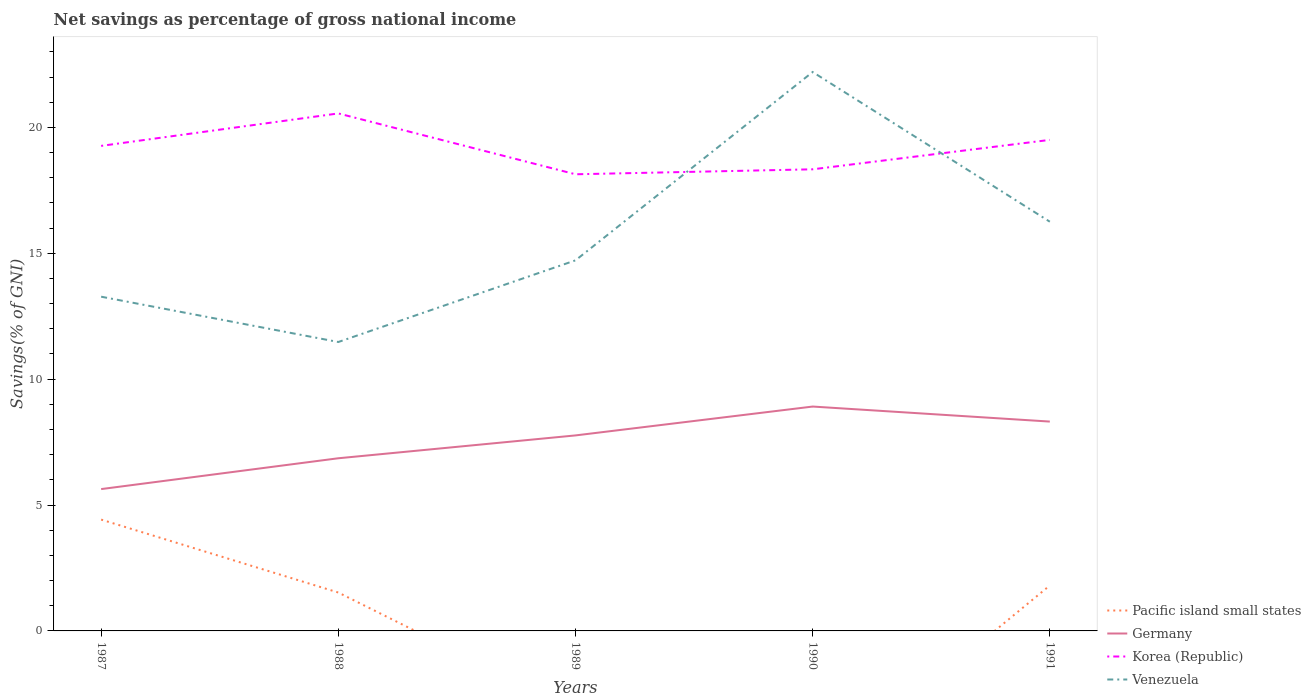Does the line corresponding to Germany intersect with the line corresponding to Korea (Republic)?
Your answer should be very brief. No. Is the number of lines equal to the number of legend labels?
Your answer should be compact. No. Across all years, what is the maximum total savings in Pacific island small states?
Offer a very short reply. 0. What is the total total savings in Venezuela in the graph?
Provide a short and direct response. -7.48. What is the difference between the highest and the second highest total savings in Pacific island small states?
Make the answer very short. 4.42. What is the difference between the highest and the lowest total savings in Venezuela?
Keep it short and to the point. 2. How many lines are there?
Your response must be concise. 4. Are the values on the major ticks of Y-axis written in scientific E-notation?
Offer a terse response. No. What is the title of the graph?
Offer a terse response. Net savings as percentage of gross national income. What is the label or title of the Y-axis?
Keep it short and to the point. Savings(% of GNI). What is the Savings(% of GNI) in Pacific island small states in 1987?
Offer a terse response. 4.42. What is the Savings(% of GNI) of Germany in 1987?
Offer a very short reply. 5.63. What is the Savings(% of GNI) in Korea (Republic) in 1987?
Give a very brief answer. 19.26. What is the Savings(% of GNI) of Venezuela in 1987?
Offer a very short reply. 13.27. What is the Savings(% of GNI) in Pacific island small states in 1988?
Your answer should be compact. 1.52. What is the Savings(% of GNI) of Germany in 1988?
Your answer should be very brief. 6.86. What is the Savings(% of GNI) of Korea (Republic) in 1988?
Provide a short and direct response. 20.55. What is the Savings(% of GNI) in Venezuela in 1988?
Your response must be concise. 11.48. What is the Savings(% of GNI) in Pacific island small states in 1989?
Your response must be concise. 0. What is the Savings(% of GNI) in Germany in 1989?
Provide a short and direct response. 7.77. What is the Savings(% of GNI) in Korea (Republic) in 1989?
Provide a succinct answer. 18.14. What is the Savings(% of GNI) of Venezuela in 1989?
Keep it short and to the point. 14.72. What is the Savings(% of GNI) in Germany in 1990?
Provide a succinct answer. 8.91. What is the Savings(% of GNI) in Korea (Republic) in 1990?
Provide a succinct answer. 18.33. What is the Savings(% of GNI) of Venezuela in 1990?
Your answer should be very brief. 22.2. What is the Savings(% of GNI) in Pacific island small states in 1991?
Give a very brief answer. 1.81. What is the Savings(% of GNI) in Germany in 1991?
Your response must be concise. 8.31. What is the Savings(% of GNI) of Korea (Republic) in 1991?
Offer a terse response. 19.5. What is the Savings(% of GNI) of Venezuela in 1991?
Provide a succinct answer. 16.25. Across all years, what is the maximum Savings(% of GNI) of Pacific island small states?
Make the answer very short. 4.42. Across all years, what is the maximum Savings(% of GNI) of Germany?
Offer a very short reply. 8.91. Across all years, what is the maximum Savings(% of GNI) of Korea (Republic)?
Offer a very short reply. 20.55. Across all years, what is the maximum Savings(% of GNI) in Venezuela?
Ensure brevity in your answer.  22.2. Across all years, what is the minimum Savings(% of GNI) in Germany?
Offer a very short reply. 5.63. Across all years, what is the minimum Savings(% of GNI) of Korea (Republic)?
Your answer should be compact. 18.14. Across all years, what is the minimum Savings(% of GNI) of Venezuela?
Your answer should be very brief. 11.48. What is the total Savings(% of GNI) of Pacific island small states in the graph?
Offer a very short reply. 7.75. What is the total Savings(% of GNI) of Germany in the graph?
Keep it short and to the point. 37.48. What is the total Savings(% of GNI) in Korea (Republic) in the graph?
Ensure brevity in your answer.  95.79. What is the total Savings(% of GNI) of Venezuela in the graph?
Keep it short and to the point. 77.92. What is the difference between the Savings(% of GNI) in Pacific island small states in 1987 and that in 1988?
Make the answer very short. 2.9. What is the difference between the Savings(% of GNI) of Germany in 1987 and that in 1988?
Offer a very short reply. -1.22. What is the difference between the Savings(% of GNI) of Korea (Republic) in 1987 and that in 1988?
Ensure brevity in your answer.  -1.29. What is the difference between the Savings(% of GNI) in Venezuela in 1987 and that in 1988?
Provide a short and direct response. 1.8. What is the difference between the Savings(% of GNI) in Germany in 1987 and that in 1989?
Your answer should be very brief. -2.13. What is the difference between the Savings(% of GNI) of Korea (Republic) in 1987 and that in 1989?
Ensure brevity in your answer.  1.13. What is the difference between the Savings(% of GNI) of Venezuela in 1987 and that in 1989?
Your answer should be very brief. -1.44. What is the difference between the Savings(% of GNI) in Germany in 1987 and that in 1990?
Your response must be concise. -3.28. What is the difference between the Savings(% of GNI) of Korea (Republic) in 1987 and that in 1990?
Give a very brief answer. 0.93. What is the difference between the Savings(% of GNI) of Venezuela in 1987 and that in 1990?
Make the answer very short. -8.92. What is the difference between the Savings(% of GNI) of Pacific island small states in 1987 and that in 1991?
Your answer should be very brief. 2.62. What is the difference between the Savings(% of GNI) in Germany in 1987 and that in 1991?
Provide a succinct answer. -2.68. What is the difference between the Savings(% of GNI) in Korea (Republic) in 1987 and that in 1991?
Offer a terse response. -0.24. What is the difference between the Savings(% of GNI) in Venezuela in 1987 and that in 1991?
Offer a terse response. -2.98. What is the difference between the Savings(% of GNI) in Germany in 1988 and that in 1989?
Your answer should be compact. -0.91. What is the difference between the Savings(% of GNI) in Korea (Republic) in 1988 and that in 1989?
Provide a succinct answer. 2.42. What is the difference between the Savings(% of GNI) in Venezuela in 1988 and that in 1989?
Give a very brief answer. -3.24. What is the difference between the Savings(% of GNI) in Germany in 1988 and that in 1990?
Your answer should be compact. -2.05. What is the difference between the Savings(% of GNI) in Korea (Republic) in 1988 and that in 1990?
Make the answer very short. 2.22. What is the difference between the Savings(% of GNI) of Venezuela in 1988 and that in 1990?
Ensure brevity in your answer.  -10.72. What is the difference between the Savings(% of GNI) of Pacific island small states in 1988 and that in 1991?
Make the answer very short. -0.28. What is the difference between the Savings(% of GNI) in Germany in 1988 and that in 1991?
Provide a short and direct response. -1.46. What is the difference between the Savings(% of GNI) in Korea (Republic) in 1988 and that in 1991?
Offer a very short reply. 1.05. What is the difference between the Savings(% of GNI) in Venezuela in 1988 and that in 1991?
Your answer should be compact. -4.78. What is the difference between the Savings(% of GNI) of Germany in 1989 and that in 1990?
Make the answer very short. -1.15. What is the difference between the Savings(% of GNI) of Korea (Republic) in 1989 and that in 1990?
Your response must be concise. -0.2. What is the difference between the Savings(% of GNI) of Venezuela in 1989 and that in 1990?
Your response must be concise. -7.48. What is the difference between the Savings(% of GNI) in Germany in 1989 and that in 1991?
Offer a terse response. -0.55. What is the difference between the Savings(% of GNI) of Korea (Republic) in 1989 and that in 1991?
Give a very brief answer. -1.37. What is the difference between the Savings(% of GNI) in Venezuela in 1989 and that in 1991?
Offer a very short reply. -1.53. What is the difference between the Savings(% of GNI) in Germany in 1990 and that in 1991?
Ensure brevity in your answer.  0.6. What is the difference between the Savings(% of GNI) of Korea (Republic) in 1990 and that in 1991?
Provide a short and direct response. -1.17. What is the difference between the Savings(% of GNI) in Venezuela in 1990 and that in 1991?
Make the answer very short. 5.95. What is the difference between the Savings(% of GNI) in Pacific island small states in 1987 and the Savings(% of GNI) in Germany in 1988?
Provide a succinct answer. -2.44. What is the difference between the Savings(% of GNI) in Pacific island small states in 1987 and the Savings(% of GNI) in Korea (Republic) in 1988?
Your response must be concise. -16.13. What is the difference between the Savings(% of GNI) in Pacific island small states in 1987 and the Savings(% of GNI) in Venezuela in 1988?
Your answer should be compact. -7.05. What is the difference between the Savings(% of GNI) of Germany in 1987 and the Savings(% of GNI) of Korea (Republic) in 1988?
Provide a succinct answer. -14.92. What is the difference between the Savings(% of GNI) of Germany in 1987 and the Savings(% of GNI) of Venezuela in 1988?
Provide a succinct answer. -5.84. What is the difference between the Savings(% of GNI) in Korea (Republic) in 1987 and the Savings(% of GNI) in Venezuela in 1988?
Ensure brevity in your answer.  7.79. What is the difference between the Savings(% of GNI) in Pacific island small states in 1987 and the Savings(% of GNI) in Germany in 1989?
Offer a very short reply. -3.34. What is the difference between the Savings(% of GNI) in Pacific island small states in 1987 and the Savings(% of GNI) in Korea (Republic) in 1989?
Offer a very short reply. -13.72. What is the difference between the Savings(% of GNI) of Pacific island small states in 1987 and the Savings(% of GNI) of Venezuela in 1989?
Offer a terse response. -10.3. What is the difference between the Savings(% of GNI) in Germany in 1987 and the Savings(% of GNI) in Korea (Republic) in 1989?
Your answer should be compact. -12.5. What is the difference between the Savings(% of GNI) of Germany in 1987 and the Savings(% of GNI) of Venezuela in 1989?
Your response must be concise. -9.09. What is the difference between the Savings(% of GNI) in Korea (Republic) in 1987 and the Savings(% of GNI) in Venezuela in 1989?
Your answer should be very brief. 4.55. What is the difference between the Savings(% of GNI) of Pacific island small states in 1987 and the Savings(% of GNI) of Germany in 1990?
Offer a terse response. -4.49. What is the difference between the Savings(% of GNI) in Pacific island small states in 1987 and the Savings(% of GNI) in Korea (Republic) in 1990?
Your response must be concise. -13.91. What is the difference between the Savings(% of GNI) in Pacific island small states in 1987 and the Savings(% of GNI) in Venezuela in 1990?
Keep it short and to the point. -17.78. What is the difference between the Savings(% of GNI) in Germany in 1987 and the Savings(% of GNI) in Korea (Republic) in 1990?
Keep it short and to the point. -12.7. What is the difference between the Savings(% of GNI) in Germany in 1987 and the Savings(% of GNI) in Venezuela in 1990?
Provide a succinct answer. -16.57. What is the difference between the Savings(% of GNI) of Korea (Republic) in 1987 and the Savings(% of GNI) of Venezuela in 1990?
Your response must be concise. -2.93. What is the difference between the Savings(% of GNI) of Pacific island small states in 1987 and the Savings(% of GNI) of Germany in 1991?
Your answer should be compact. -3.89. What is the difference between the Savings(% of GNI) in Pacific island small states in 1987 and the Savings(% of GNI) in Korea (Republic) in 1991?
Keep it short and to the point. -15.08. What is the difference between the Savings(% of GNI) in Pacific island small states in 1987 and the Savings(% of GNI) in Venezuela in 1991?
Keep it short and to the point. -11.83. What is the difference between the Savings(% of GNI) of Germany in 1987 and the Savings(% of GNI) of Korea (Republic) in 1991?
Your answer should be compact. -13.87. What is the difference between the Savings(% of GNI) in Germany in 1987 and the Savings(% of GNI) in Venezuela in 1991?
Ensure brevity in your answer.  -10.62. What is the difference between the Savings(% of GNI) of Korea (Republic) in 1987 and the Savings(% of GNI) of Venezuela in 1991?
Provide a short and direct response. 3.01. What is the difference between the Savings(% of GNI) in Pacific island small states in 1988 and the Savings(% of GNI) in Germany in 1989?
Your response must be concise. -6.24. What is the difference between the Savings(% of GNI) of Pacific island small states in 1988 and the Savings(% of GNI) of Korea (Republic) in 1989?
Provide a succinct answer. -16.61. What is the difference between the Savings(% of GNI) of Pacific island small states in 1988 and the Savings(% of GNI) of Venezuela in 1989?
Give a very brief answer. -13.19. What is the difference between the Savings(% of GNI) of Germany in 1988 and the Savings(% of GNI) of Korea (Republic) in 1989?
Your answer should be compact. -11.28. What is the difference between the Savings(% of GNI) of Germany in 1988 and the Savings(% of GNI) of Venezuela in 1989?
Make the answer very short. -7.86. What is the difference between the Savings(% of GNI) of Korea (Republic) in 1988 and the Savings(% of GNI) of Venezuela in 1989?
Keep it short and to the point. 5.84. What is the difference between the Savings(% of GNI) in Pacific island small states in 1988 and the Savings(% of GNI) in Germany in 1990?
Provide a succinct answer. -7.39. What is the difference between the Savings(% of GNI) of Pacific island small states in 1988 and the Savings(% of GNI) of Korea (Republic) in 1990?
Give a very brief answer. -16.81. What is the difference between the Savings(% of GNI) in Pacific island small states in 1988 and the Savings(% of GNI) in Venezuela in 1990?
Offer a terse response. -20.67. What is the difference between the Savings(% of GNI) of Germany in 1988 and the Savings(% of GNI) of Korea (Republic) in 1990?
Offer a very short reply. -11.48. What is the difference between the Savings(% of GNI) of Germany in 1988 and the Savings(% of GNI) of Venezuela in 1990?
Your answer should be very brief. -15.34. What is the difference between the Savings(% of GNI) of Korea (Republic) in 1988 and the Savings(% of GNI) of Venezuela in 1990?
Keep it short and to the point. -1.64. What is the difference between the Savings(% of GNI) of Pacific island small states in 1988 and the Savings(% of GNI) of Germany in 1991?
Offer a very short reply. -6.79. What is the difference between the Savings(% of GNI) of Pacific island small states in 1988 and the Savings(% of GNI) of Korea (Republic) in 1991?
Your answer should be compact. -17.98. What is the difference between the Savings(% of GNI) in Pacific island small states in 1988 and the Savings(% of GNI) in Venezuela in 1991?
Offer a very short reply. -14.73. What is the difference between the Savings(% of GNI) in Germany in 1988 and the Savings(% of GNI) in Korea (Republic) in 1991?
Ensure brevity in your answer.  -12.65. What is the difference between the Savings(% of GNI) of Germany in 1988 and the Savings(% of GNI) of Venezuela in 1991?
Keep it short and to the point. -9.4. What is the difference between the Savings(% of GNI) in Korea (Republic) in 1988 and the Savings(% of GNI) in Venezuela in 1991?
Your response must be concise. 4.3. What is the difference between the Savings(% of GNI) in Germany in 1989 and the Savings(% of GNI) in Korea (Republic) in 1990?
Offer a terse response. -10.57. What is the difference between the Savings(% of GNI) of Germany in 1989 and the Savings(% of GNI) of Venezuela in 1990?
Provide a succinct answer. -14.43. What is the difference between the Savings(% of GNI) in Korea (Republic) in 1989 and the Savings(% of GNI) in Venezuela in 1990?
Offer a terse response. -4.06. What is the difference between the Savings(% of GNI) in Germany in 1989 and the Savings(% of GNI) in Korea (Republic) in 1991?
Ensure brevity in your answer.  -11.74. What is the difference between the Savings(% of GNI) of Germany in 1989 and the Savings(% of GNI) of Venezuela in 1991?
Keep it short and to the point. -8.49. What is the difference between the Savings(% of GNI) in Korea (Republic) in 1989 and the Savings(% of GNI) in Venezuela in 1991?
Provide a succinct answer. 1.88. What is the difference between the Savings(% of GNI) of Germany in 1990 and the Savings(% of GNI) of Korea (Republic) in 1991?
Your answer should be very brief. -10.59. What is the difference between the Savings(% of GNI) of Germany in 1990 and the Savings(% of GNI) of Venezuela in 1991?
Make the answer very short. -7.34. What is the difference between the Savings(% of GNI) in Korea (Republic) in 1990 and the Savings(% of GNI) in Venezuela in 1991?
Your answer should be compact. 2.08. What is the average Savings(% of GNI) of Pacific island small states per year?
Give a very brief answer. 1.55. What is the average Savings(% of GNI) in Germany per year?
Provide a succinct answer. 7.5. What is the average Savings(% of GNI) of Korea (Republic) per year?
Make the answer very short. 19.16. What is the average Savings(% of GNI) in Venezuela per year?
Your response must be concise. 15.58. In the year 1987, what is the difference between the Savings(% of GNI) of Pacific island small states and Savings(% of GNI) of Germany?
Give a very brief answer. -1.21. In the year 1987, what is the difference between the Savings(% of GNI) of Pacific island small states and Savings(% of GNI) of Korea (Republic)?
Keep it short and to the point. -14.84. In the year 1987, what is the difference between the Savings(% of GNI) in Pacific island small states and Savings(% of GNI) in Venezuela?
Your response must be concise. -8.85. In the year 1987, what is the difference between the Savings(% of GNI) of Germany and Savings(% of GNI) of Korea (Republic)?
Your response must be concise. -13.63. In the year 1987, what is the difference between the Savings(% of GNI) in Germany and Savings(% of GNI) in Venezuela?
Make the answer very short. -7.64. In the year 1987, what is the difference between the Savings(% of GNI) in Korea (Republic) and Savings(% of GNI) in Venezuela?
Ensure brevity in your answer.  5.99. In the year 1988, what is the difference between the Savings(% of GNI) in Pacific island small states and Savings(% of GNI) in Germany?
Make the answer very short. -5.33. In the year 1988, what is the difference between the Savings(% of GNI) in Pacific island small states and Savings(% of GNI) in Korea (Republic)?
Keep it short and to the point. -19.03. In the year 1988, what is the difference between the Savings(% of GNI) of Pacific island small states and Savings(% of GNI) of Venezuela?
Your response must be concise. -9.95. In the year 1988, what is the difference between the Savings(% of GNI) in Germany and Savings(% of GNI) in Korea (Republic)?
Give a very brief answer. -13.7. In the year 1988, what is the difference between the Savings(% of GNI) in Germany and Savings(% of GNI) in Venezuela?
Your answer should be compact. -4.62. In the year 1988, what is the difference between the Savings(% of GNI) of Korea (Republic) and Savings(% of GNI) of Venezuela?
Ensure brevity in your answer.  9.08. In the year 1989, what is the difference between the Savings(% of GNI) of Germany and Savings(% of GNI) of Korea (Republic)?
Make the answer very short. -10.37. In the year 1989, what is the difference between the Savings(% of GNI) in Germany and Savings(% of GNI) in Venezuela?
Give a very brief answer. -6.95. In the year 1989, what is the difference between the Savings(% of GNI) of Korea (Republic) and Savings(% of GNI) of Venezuela?
Ensure brevity in your answer.  3.42. In the year 1990, what is the difference between the Savings(% of GNI) in Germany and Savings(% of GNI) in Korea (Republic)?
Offer a terse response. -9.42. In the year 1990, what is the difference between the Savings(% of GNI) of Germany and Savings(% of GNI) of Venezuela?
Offer a terse response. -13.29. In the year 1990, what is the difference between the Savings(% of GNI) of Korea (Republic) and Savings(% of GNI) of Venezuela?
Give a very brief answer. -3.86. In the year 1991, what is the difference between the Savings(% of GNI) in Pacific island small states and Savings(% of GNI) in Germany?
Your response must be concise. -6.51. In the year 1991, what is the difference between the Savings(% of GNI) in Pacific island small states and Savings(% of GNI) in Korea (Republic)?
Make the answer very short. -17.7. In the year 1991, what is the difference between the Savings(% of GNI) of Pacific island small states and Savings(% of GNI) of Venezuela?
Provide a succinct answer. -14.45. In the year 1991, what is the difference between the Savings(% of GNI) of Germany and Savings(% of GNI) of Korea (Republic)?
Provide a short and direct response. -11.19. In the year 1991, what is the difference between the Savings(% of GNI) of Germany and Savings(% of GNI) of Venezuela?
Give a very brief answer. -7.94. In the year 1991, what is the difference between the Savings(% of GNI) of Korea (Republic) and Savings(% of GNI) of Venezuela?
Offer a very short reply. 3.25. What is the ratio of the Savings(% of GNI) in Pacific island small states in 1987 to that in 1988?
Your answer should be very brief. 2.9. What is the ratio of the Savings(% of GNI) in Germany in 1987 to that in 1988?
Make the answer very short. 0.82. What is the ratio of the Savings(% of GNI) in Korea (Republic) in 1987 to that in 1988?
Offer a very short reply. 0.94. What is the ratio of the Savings(% of GNI) in Venezuela in 1987 to that in 1988?
Your answer should be very brief. 1.16. What is the ratio of the Savings(% of GNI) in Germany in 1987 to that in 1989?
Make the answer very short. 0.73. What is the ratio of the Savings(% of GNI) of Korea (Republic) in 1987 to that in 1989?
Your response must be concise. 1.06. What is the ratio of the Savings(% of GNI) in Venezuela in 1987 to that in 1989?
Keep it short and to the point. 0.9. What is the ratio of the Savings(% of GNI) of Germany in 1987 to that in 1990?
Your response must be concise. 0.63. What is the ratio of the Savings(% of GNI) of Korea (Republic) in 1987 to that in 1990?
Ensure brevity in your answer.  1.05. What is the ratio of the Savings(% of GNI) of Venezuela in 1987 to that in 1990?
Give a very brief answer. 0.6. What is the ratio of the Savings(% of GNI) in Pacific island small states in 1987 to that in 1991?
Make the answer very short. 2.45. What is the ratio of the Savings(% of GNI) of Germany in 1987 to that in 1991?
Provide a succinct answer. 0.68. What is the ratio of the Savings(% of GNI) in Venezuela in 1987 to that in 1991?
Make the answer very short. 0.82. What is the ratio of the Savings(% of GNI) in Germany in 1988 to that in 1989?
Your response must be concise. 0.88. What is the ratio of the Savings(% of GNI) in Korea (Republic) in 1988 to that in 1989?
Offer a terse response. 1.13. What is the ratio of the Savings(% of GNI) of Venezuela in 1988 to that in 1989?
Keep it short and to the point. 0.78. What is the ratio of the Savings(% of GNI) in Germany in 1988 to that in 1990?
Your answer should be compact. 0.77. What is the ratio of the Savings(% of GNI) in Korea (Republic) in 1988 to that in 1990?
Keep it short and to the point. 1.12. What is the ratio of the Savings(% of GNI) of Venezuela in 1988 to that in 1990?
Your response must be concise. 0.52. What is the ratio of the Savings(% of GNI) in Pacific island small states in 1988 to that in 1991?
Provide a short and direct response. 0.84. What is the ratio of the Savings(% of GNI) of Germany in 1988 to that in 1991?
Provide a short and direct response. 0.82. What is the ratio of the Savings(% of GNI) of Korea (Republic) in 1988 to that in 1991?
Offer a very short reply. 1.05. What is the ratio of the Savings(% of GNI) in Venezuela in 1988 to that in 1991?
Keep it short and to the point. 0.71. What is the ratio of the Savings(% of GNI) in Germany in 1989 to that in 1990?
Your answer should be compact. 0.87. What is the ratio of the Savings(% of GNI) of Korea (Republic) in 1989 to that in 1990?
Offer a terse response. 0.99. What is the ratio of the Savings(% of GNI) of Venezuela in 1989 to that in 1990?
Provide a succinct answer. 0.66. What is the ratio of the Savings(% of GNI) in Germany in 1989 to that in 1991?
Offer a terse response. 0.93. What is the ratio of the Savings(% of GNI) of Korea (Republic) in 1989 to that in 1991?
Offer a terse response. 0.93. What is the ratio of the Savings(% of GNI) in Venezuela in 1989 to that in 1991?
Your answer should be very brief. 0.91. What is the ratio of the Savings(% of GNI) of Germany in 1990 to that in 1991?
Provide a succinct answer. 1.07. What is the ratio of the Savings(% of GNI) of Korea (Republic) in 1990 to that in 1991?
Offer a very short reply. 0.94. What is the ratio of the Savings(% of GNI) in Venezuela in 1990 to that in 1991?
Provide a succinct answer. 1.37. What is the difference between the highest and the second highest Savings(% of GNI) in Pacific island small states?
Offer a terse response. 2.62. What is the difference between the highest and the second highest Savings(% of GNI) in Germany?
Your answer should be very brief. 0.6. What is the difference between the highest and the second highest Savings(% of GNI) in Korea (Republic)?
Offer a very short reply. 1.05. What is the difference between the highest and the second highest Savings(% of GNI) of Venezuela?
Your answer should be compact. 5.95. What is the difference between the highest and the lowest Savings(% of GNI) in Pacific island small states?
Your answer should be compact. 4.42. What is the difference between the highest and the lowest Savings(% of GNI) in Germany?
Your response must be concise. 3.28. What is the difference between the highest and the lowest Savings(% of GNI) of Korea (Republic)?
Provide a short and direct response. 2.42. What is the difference between the highest and the lowest Savings(% of GNI) in Venezuela?
Your answer should be very brief. 10.72. 